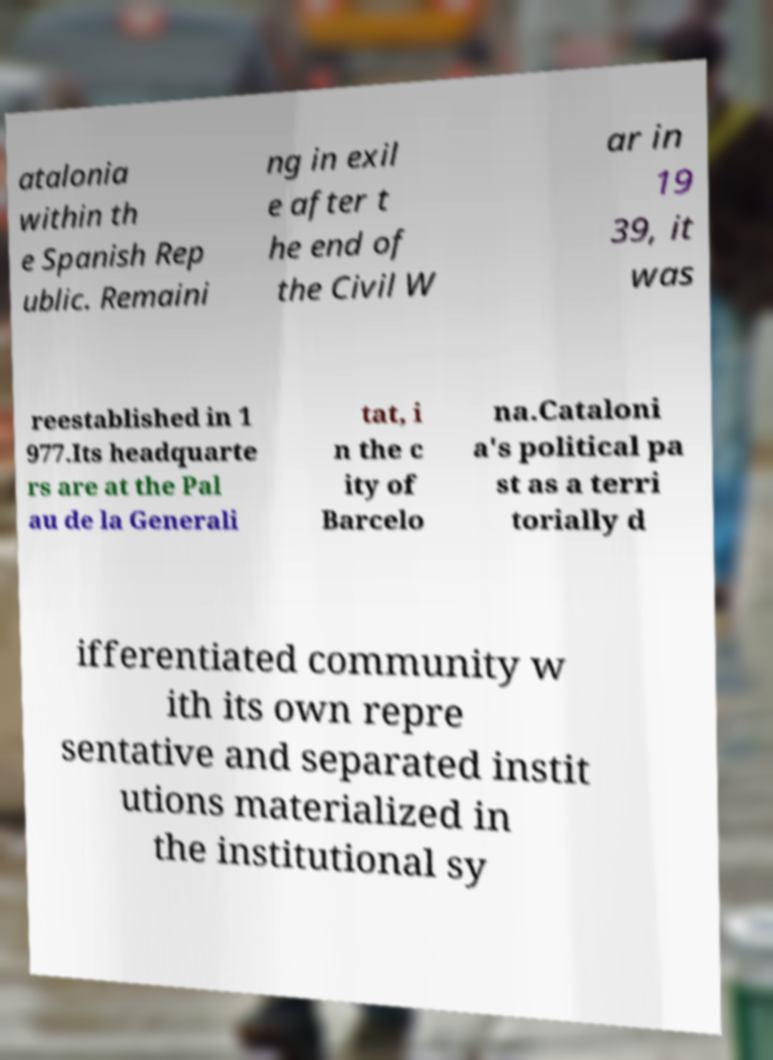There's text embedded in this image that I need extracted. Can you transcribe it verbatim? atalonia within th e Spanish Rep ublic. Remaini ng in exil e after t he end of the Civil W ar in 19 39, it was reestablished in 1 977.Its headquarte rs are at the Pal au de la Generali tat, i n the c ity of Barcelo na.Cataloni a's political pa st as a terri torially d ifferentiated community w ith its own repre sentative and separated instit utions materialized in the institutional sy 